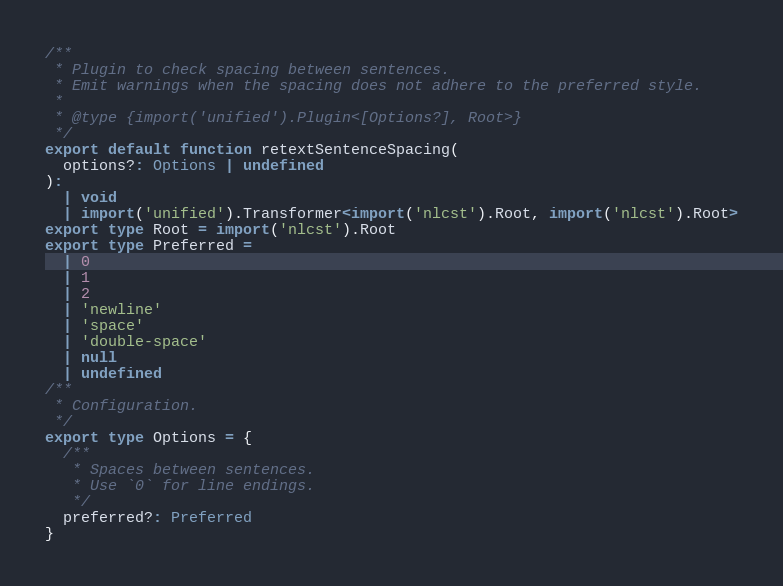Convert code to text. <code><loc_0><loc_0><loc_500><loc_500><_TypeScript_>/**
 * Plugin to check spacing between sentences.
 * Emit warnings when the spacing does not adhere to the preferred style.
 *
 * @type {import('unified').Plugin<[Options?], Root>}
 */
export default function retextSentenceSpacing(
  options?: Options | undefined
):
  | void
  | import('unified').Transformer<import('nlcst').Root, import('nlcst').Root>
export type Root = import('nlcst').Root
export type Preferred =
  | 0
  | 1
  | 2
  | 'newline'
  | 'space'
  | 'double-space'
  | null
  | undefined
/**
 * Configuration.
 */
export type Options = {
  /**
   * Spaces between sentences.
   * Use `0` for line endings.
   */
  preferred?: Preferred
}
</code> 